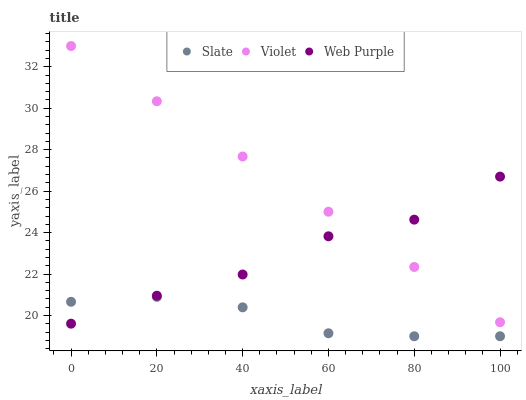Does Slate have the minimum area under the curve?
Answer yes or no. Yes. Does Violet have the maximum area under the curve?
Answer yes or no. Yes. Does Web Purple have the minimum area under the curve?
Answer yes or no. No. Does Web Purple have the maximum area under the curve?
Answer yes or no. No. Is Violet the smoothest?
Answer yes or no. Yes. Is Web Purple the roughest?
Answer yes or no. Yes. Is Web Purple the smoothest?
Answer yes or no. No. Is Violet the roughest?
Answer yes or no. No. Does Slate have the lowest value?
Answer yes or no. Yes. Does Web Purple have the lowest value?
Answer yes or no. No. Does Violet have the highest value?
Answer yes or no. Yes. Does Web Purple have the highest value?
Answer yes or no. No. Is Slate less than Violet?
Answer yes or no. Yes. Is Violet greater than Slate?
Answer yes or no. Yes. Does Web Purple intersect Violet?
Answer yes or no. Yes. Is Web Purple less than Violet?
Answer yes or no. No. Is Web Purple greater than Violet?
Answer yes or no. No. Does Slate intersect Violet?
Answer yes or no. No. 